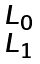<formula> <loc_0><loc_0><loc_500><loc_500>\begin{smallmatrix} L _ { 0 } \\ L _ { 1 } \end{smallmatrix}</formula> 